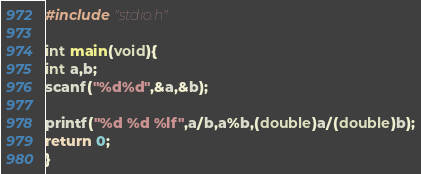Convert code to text. <code><loc_0><loc_0><loc_500><loc_500><_C_>#include "stdio.h"

int main(void){
int a,b;
scanf("%d%d",&a,&b);

printf("%d %d %lf",a/b,a%b,(double)a/(double)b);
return 0;
}</code> 